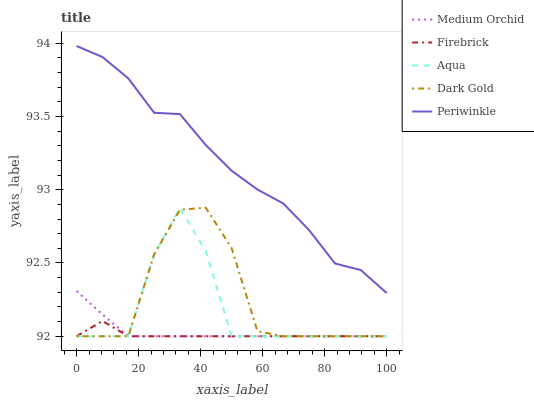Does Firebrick have the minimum area under the curve?
Answer yes or no. Yes. Does Periwinkle have the maximum area under the curve?
Answer yes or no. Yes. Does Medium Orchid have the minimum area under the curve?
Answer yes or no. No. Does Medium Orchid have the maximum area under the curve?
Answer yes or no. No. Is Medium Orchid the smoothest?
Answer yes or no. Yes. Is Aqua the roughest?
Answer yes or no. Yes. Is Firebrick the smoothest?
Answer yes or no. No. Is Firebrick the roughest?
Answer yes or no. No. Does Firebrick have the lowest value?
Answer yes or no. Yes. Does Periwinkle have the highest value?
Answer yes or no. Yes. Does Medium Orchid have the highest value?
Answer yes or no. No. Is Medium Orchid less than Periwinkle?
Answer yes or no. Yes. Is Periwinkle greater than Firebrick?
Answer yes or no. Yes. Does Aqua intersect Firebrick?
Answer yes or no. Yes. Is Aqua less than Firebrick?
Answer yes or no. No. Is Aqua greater than Firebrick?
Answer yes or no. No. Does Medium Orchid intersect Periwinkle?
Answer yes or no. No. 